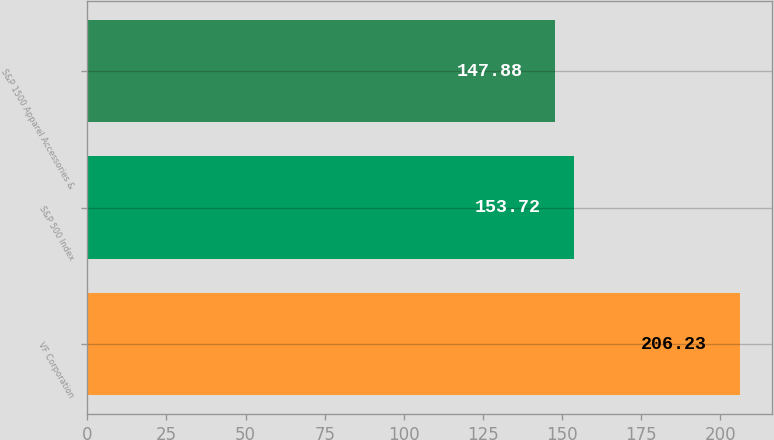<chart> <loc_0><loc_0><loc_500><loc_500><bar_chart><fcel>VF Corporation<fcel>S&P 500 Index<fcel>S&P 1500 Apparel Accessories &<nl><fcel>206.23<fcel>153.72<fcel>147.88<nl></chart> 